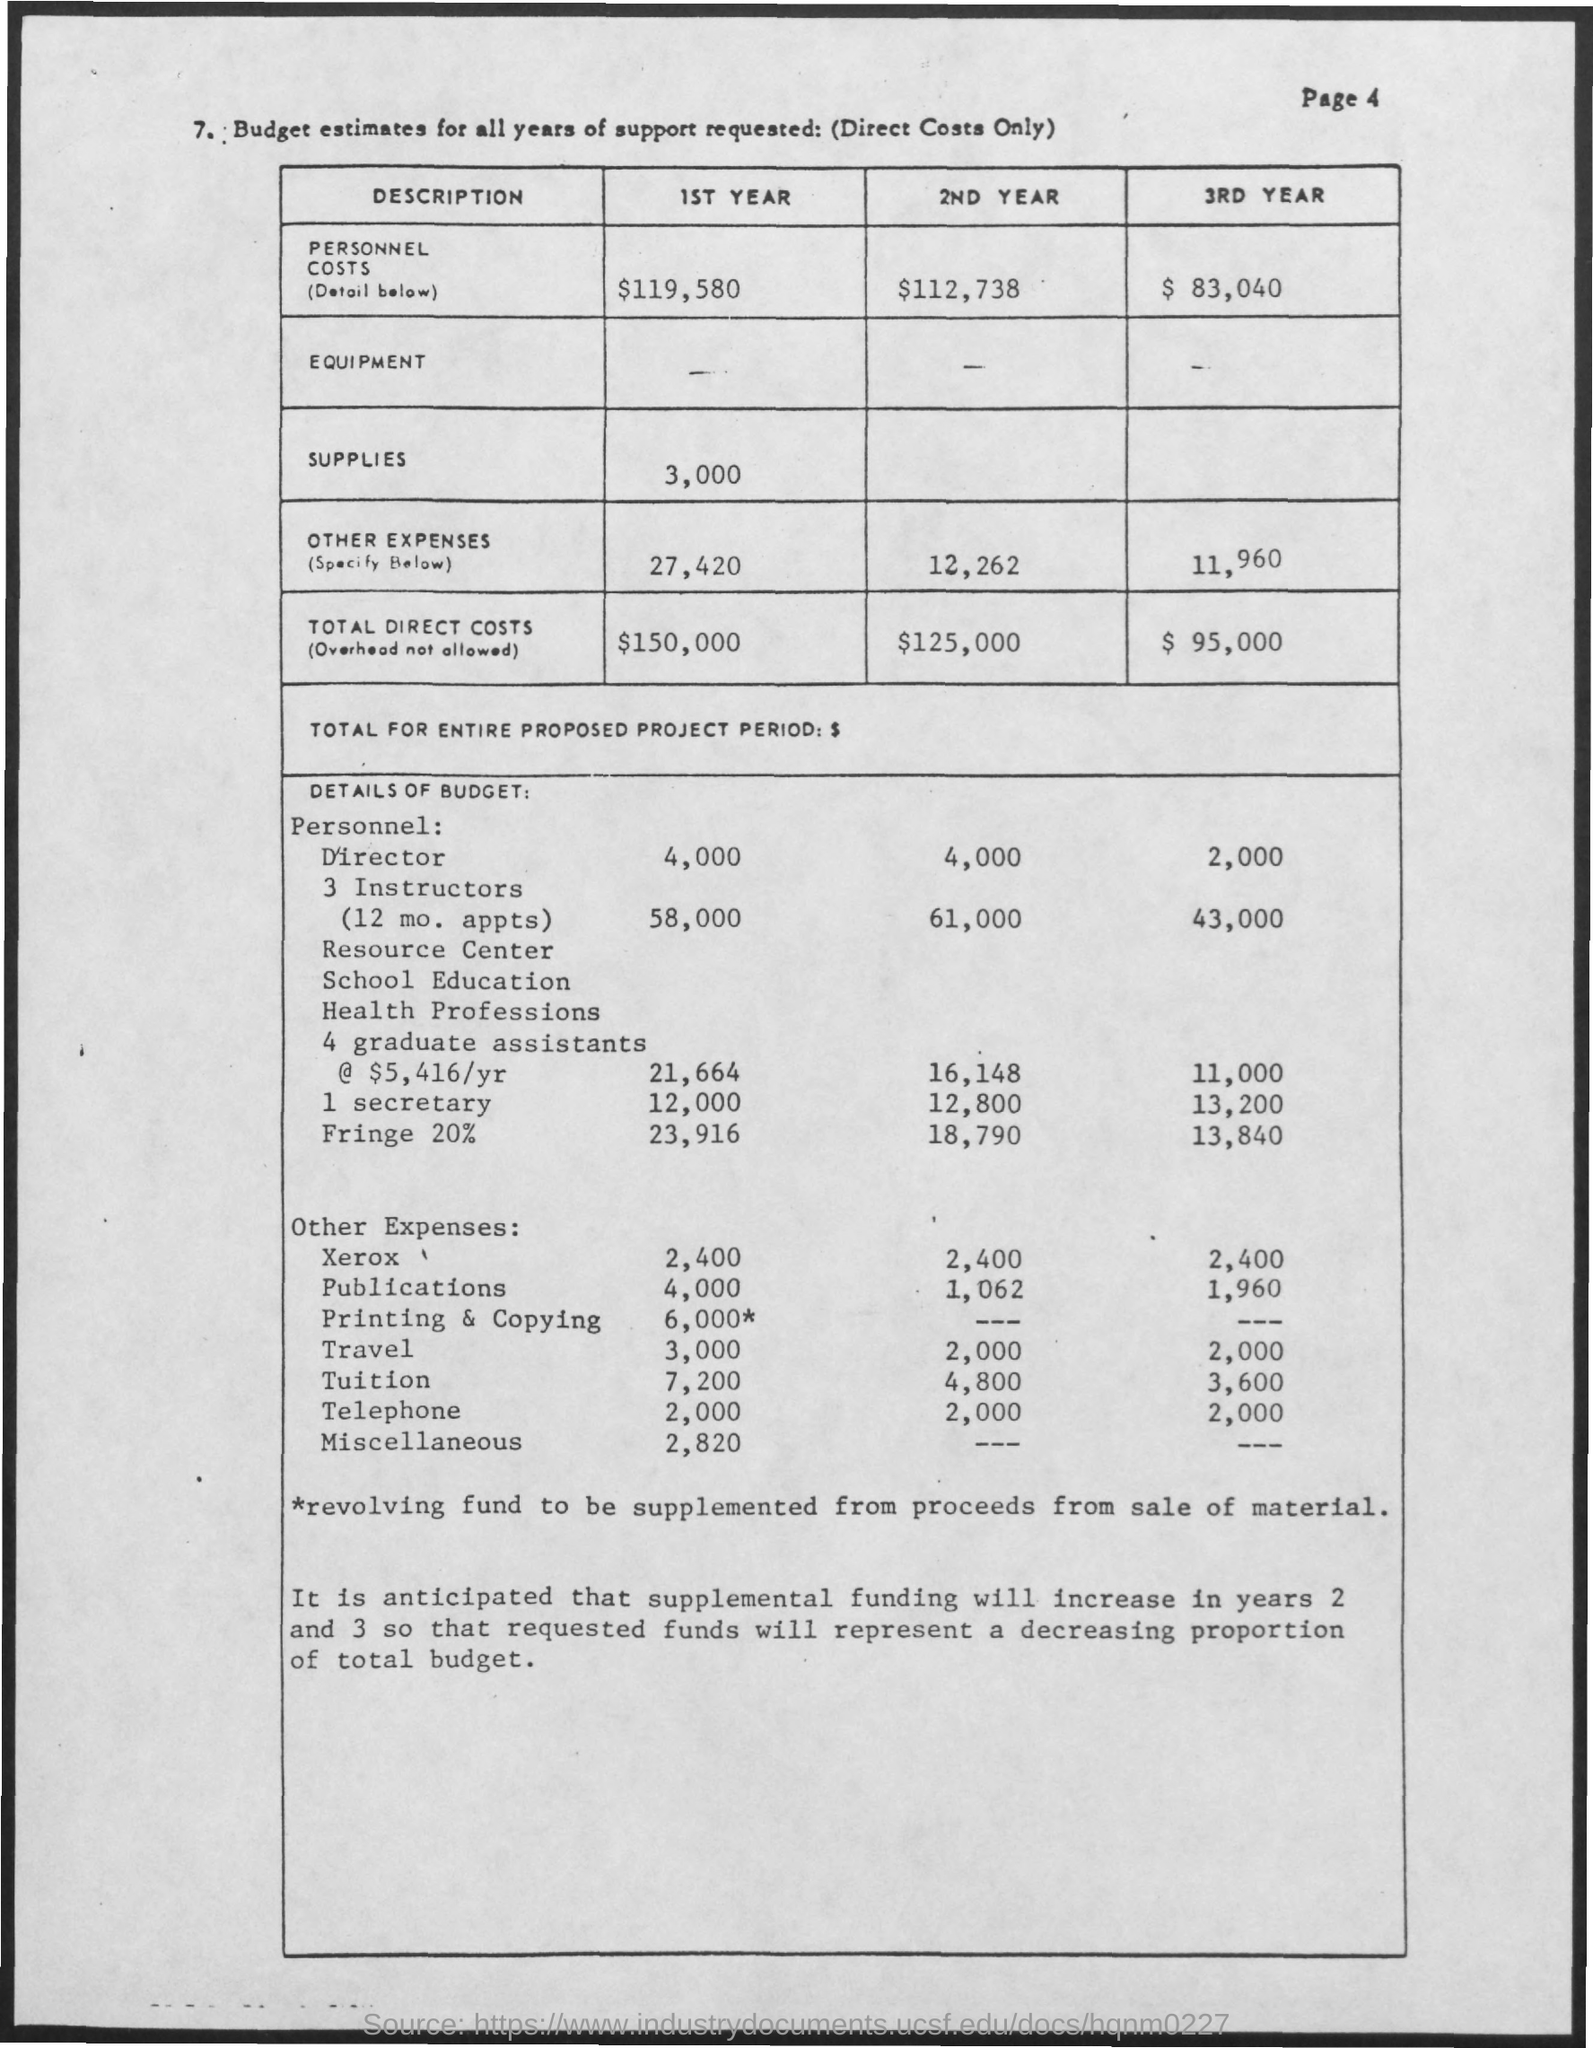What is the page number?
Provide a succinct answer. 4. What is the table heading?
Your response must be concise. Budget estimates for all years of support requested: (direct costs only). How much is the supplies cost for the 1st year?
Offer a terse response. 3,000. What is the total direct costs for the 2nd year?
Provide a short and direct response. $125,000. 